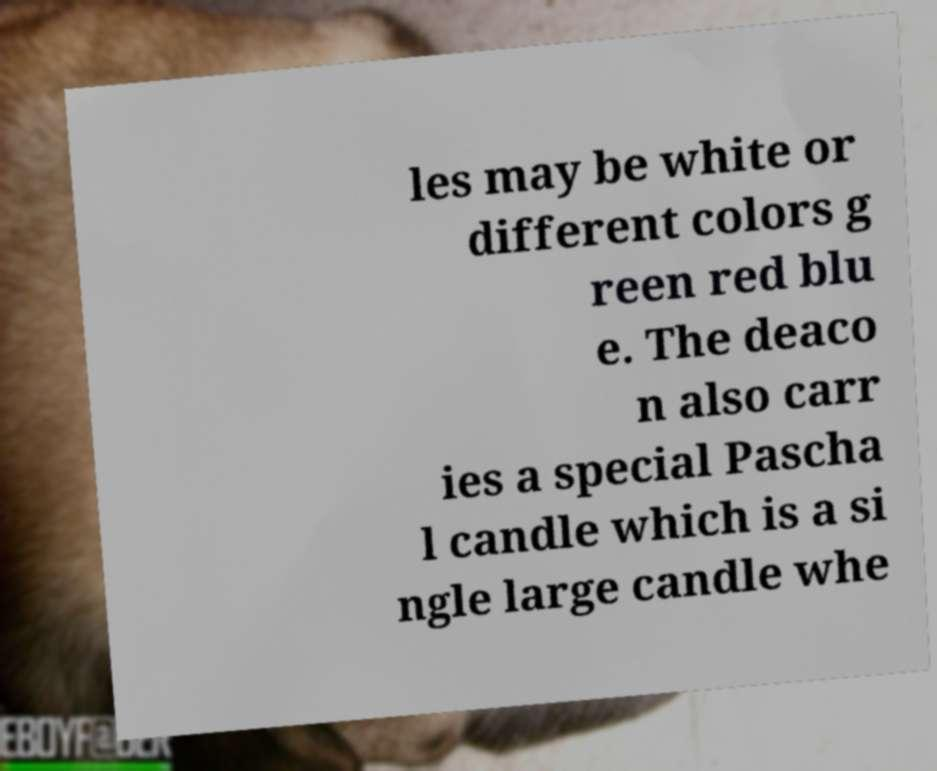What messages or text are displayed in this image? I need them in a readable, typed format. les may be white or different colors g reen red blu e. The deaco n also carr ies a special Pascha l candle which is a si ngle large candle whe 